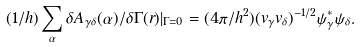<formula> <loc_0><loc_0><loc_500><loc_500>( 1 / h ) \sum _ { \alpha } \delta { A } _ { \gamma \delta } ( \alpha ) / \delta \Gamma ( { r } ) | _ { \Gamma = 0 } = ( 4 \pi / h ^ { 2 } ) ( v _ { \gamma } v _ { \delta } ) ^ { - 1 / 2 } \psi ^ { \ast } _ { \gamma } \psi _ { \delta } .</formula> 